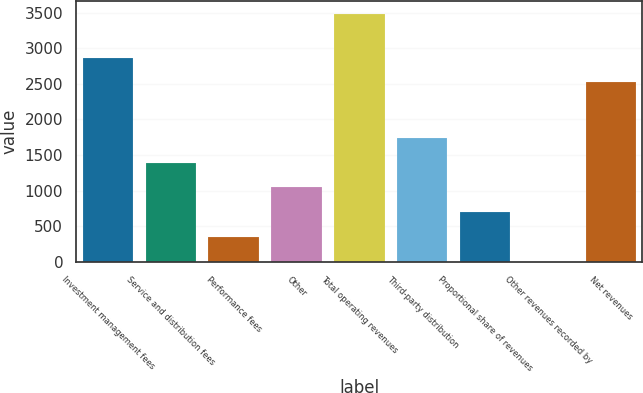Convert chart to OTSL. <chart><loc_0><loc_0><loc_500><loc_500><bar_chart><fcel>Investment management fees<fcel>Service and distribution fees<fcel>Performance fees<fcel>Other<fcel>Total operating revenues<fcel>Third-party distribution<fcel>Proportional share of revenues<fcel>Other revenues recorded by<fcel>Net revenues<nl><fcel>2869.84<fcel>1395.26<fcel>349.04<fcel>1046.52<fcel>3487.7<fcel>1744<fcel>697.78<fcel>0.3<fcel>2521.1<nl></chart> 